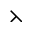<formula> <loc_0><loc_0><loc_500><loc_500>\left t h r e e t i m e s</formula> 